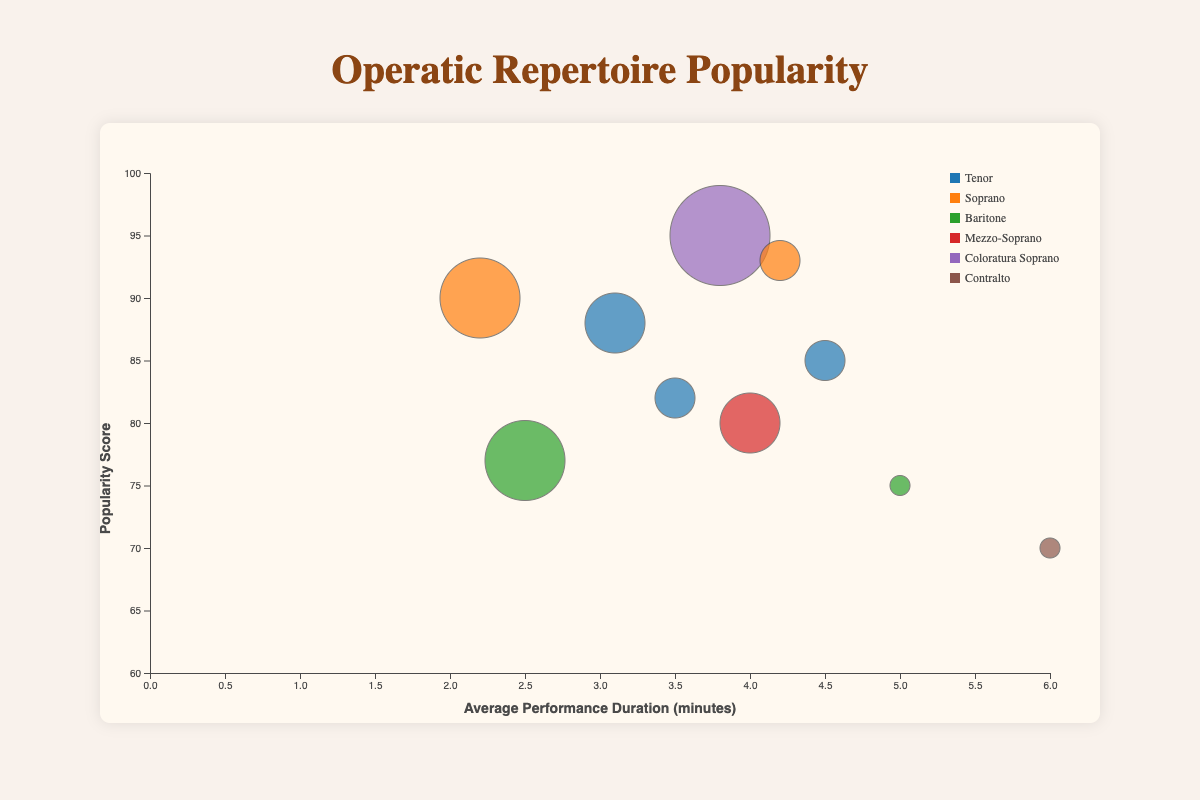What is the title of the figure? The title of the figure is usually displayed prominently at the top. In this case, it is "Operatic Repertoire Popularity."
Answer: Operatic Repertoire Popularity How many different vocal ranges are represented in the chart? The legend in the chart shows the different colors corresponding to the vocal ranges. Each color represents one vocal range, which can be counted.
Answer: 6 Which repertoire has the highest popularity score? Look at the positioning of the bubbles along the y-axis, which represents the popularity score. The bubble with the highest y-coordinate has the highest popularity score.
Answer: Der Hölle Rache What is the average performance duration of "Ave Maria"? Find the bubble corresponding to "Ave Maria." The x-coordinate of the bubble represents the average performance duration.
Answer: 4.2 minutes Which vocal range has the bubble with the largest size, and what does it represent? The size of the bubble corresponds to the historical trend. Find the bubble with the largest diameter and note the vocal range and historical trend value.
Answer: Coloratura Soprano, 0.6 Compared to "Nessun Dorma," how much more popular is "O Mio Babbino Caro"? Find the y-coordinates of "Nessun Dorma" and "O Mio Babbino Caro" and subtract the popularity score of "Nessun Dorma" from that of "O Mio Babbino Caro."
Answer: 90 - 85 = 5 Which piece has the longest average performance duration? Look for the bubble positioned furthest along the x-axis to the right, which represents the longest average performance duration.
Answer: Una voce poco fa How does the historical trend of "Vesti la giubba" compare to "Habanera"? Identify the bubbles for "Vesti la giubba" and "Habanera," and compare their sizes since the size represents the historical trend.
Answer: Vesti la giubba: 0.3, Habanera: 0.4 What is the average historical trend of the soprano vocal range pieces? Identify the bubbles for the soprano pieces ("O Mio Babbino Caro" and "Ave Maria"), add their historical trend values, and divide by the number of pieces. (0.5 + 0.3) / 2 = 0.4
Answer: 0.4 Which repertoire among the Baritone vocal range has the higher popularity score? Compare the y-coordinates of the bubbles representing Baritone pieces ("Largo al factotum" and "Don Giovanni: Champagne Aria") to see which has the higher popularity score.
Answer: Don Giovanni: Champagne Aria 